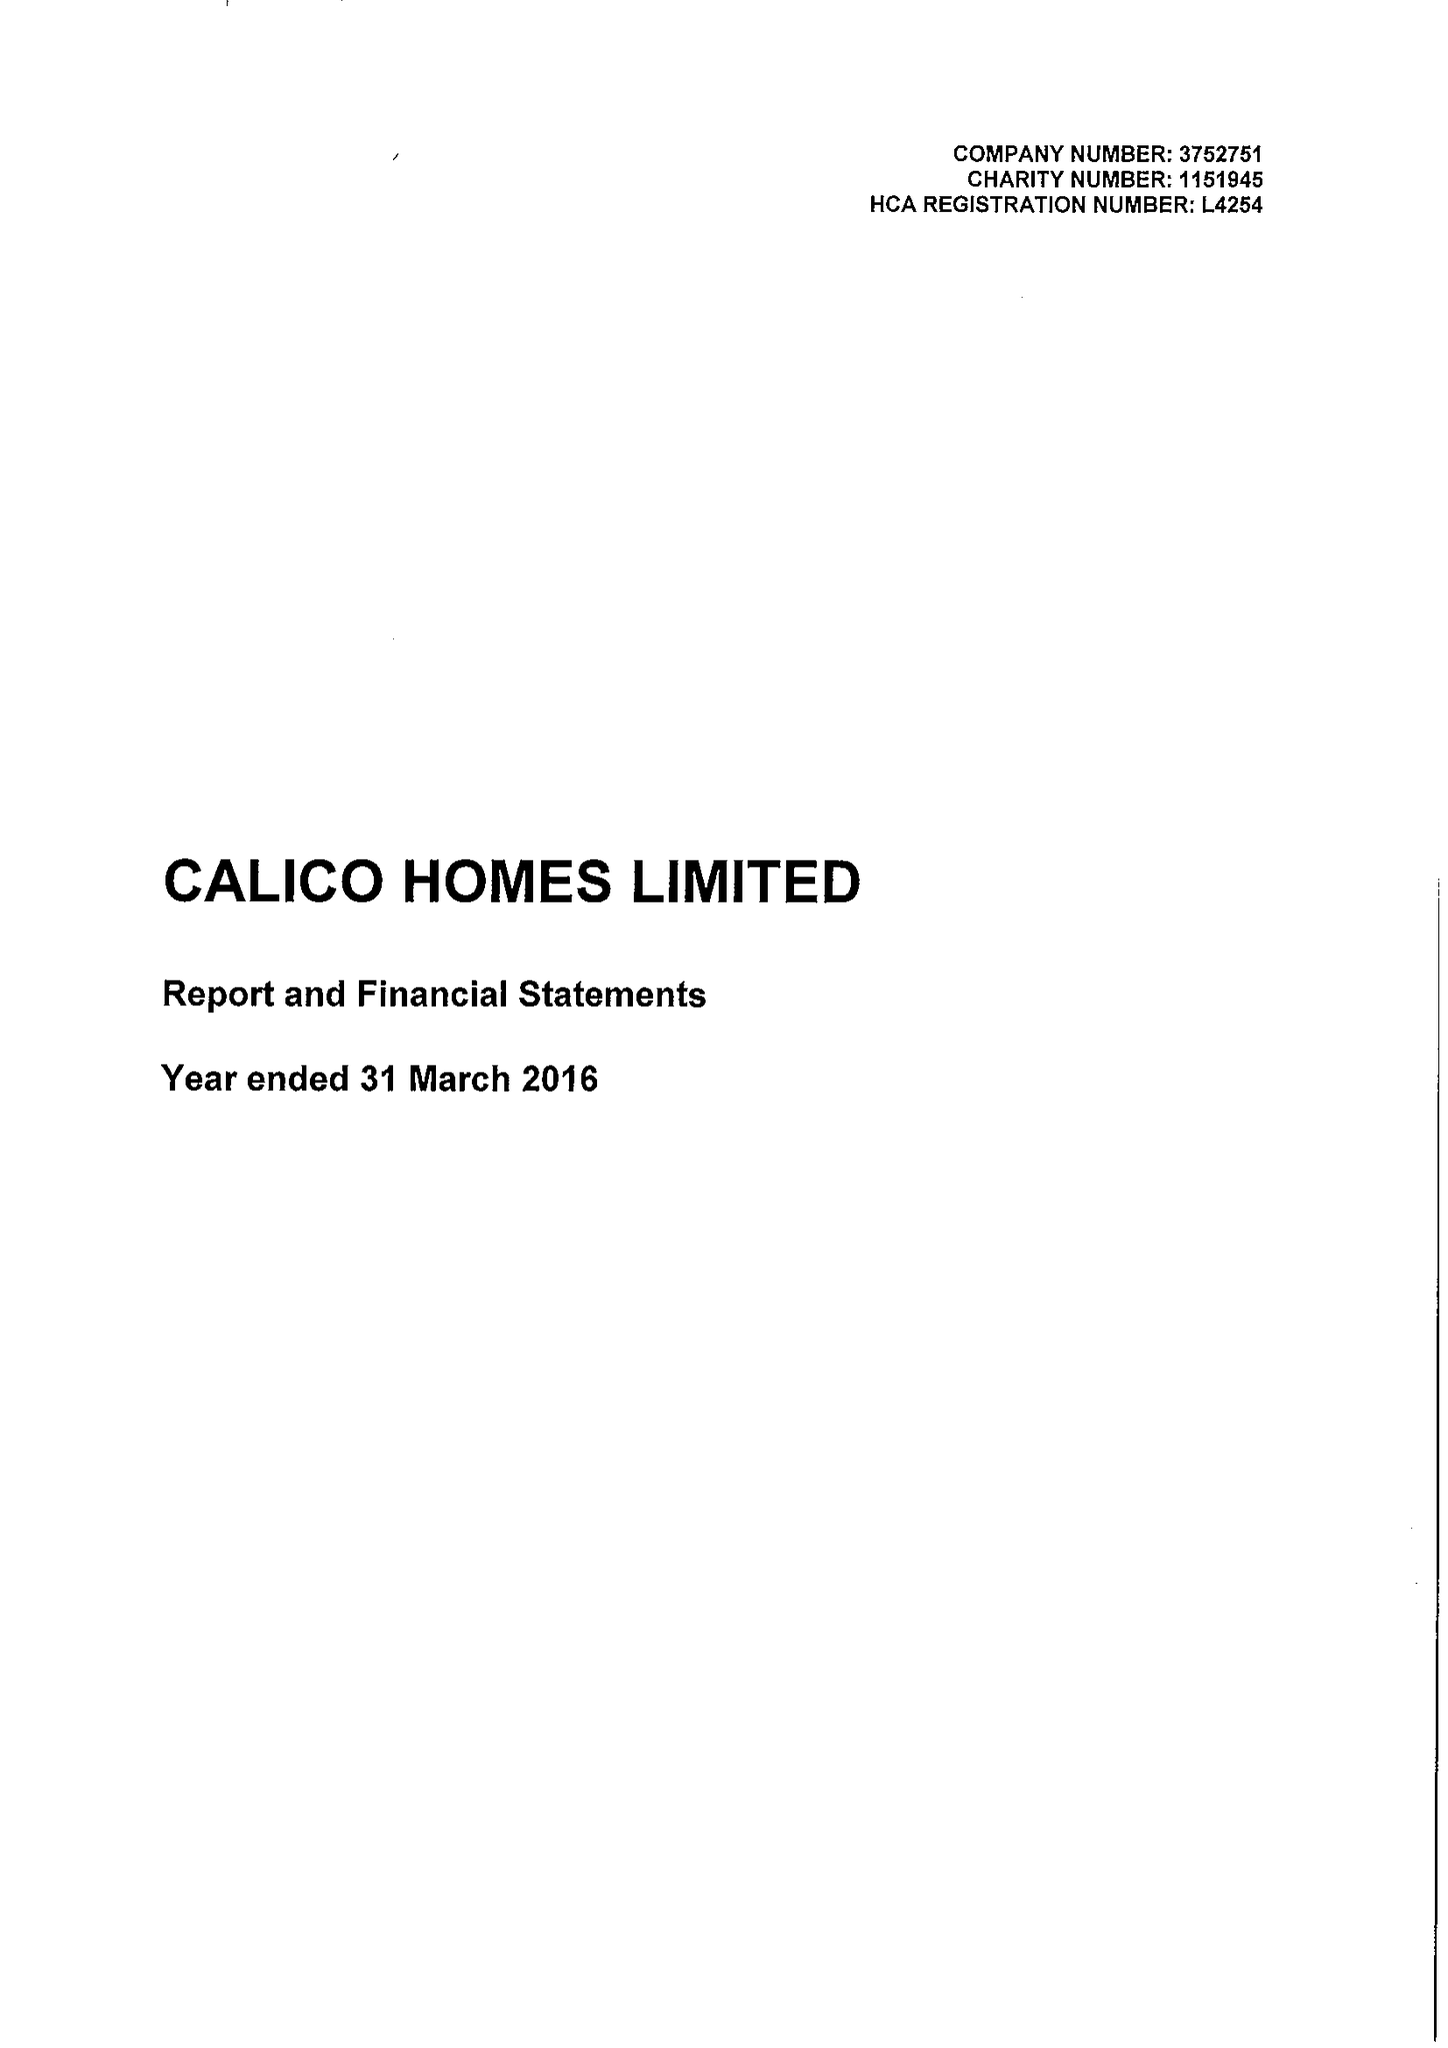What is the value for the address__postcode?
Answer the question using a single word or phrase. BB11 2ED 